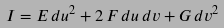Convert formula to latex. <formula><loc_0><loc_0><loc_500><loc_500>I = E \, d u ^ { 2 } + 2 \, F \, d u \, d v + G \, d v ^ { 2 }</formula> 